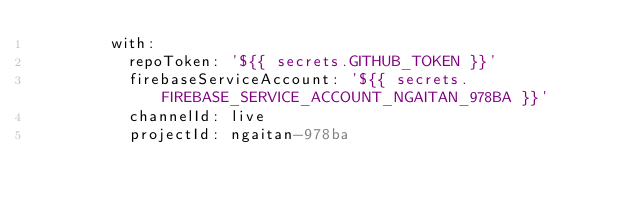Convert code to text. <code><loc_0><loc_0><loc_500><loc_500><_YAML_>        with:
          repoToken: '${{ secrets.GITHUB_TOKEN }}'
          firebaseServiceAccount: '${{ secrets.FIREBASE_SERVICE_ACCOUNT_NGAITAN_978BA }}'
          channelId: live
          projectId: ngaitan-978ba
</code> 